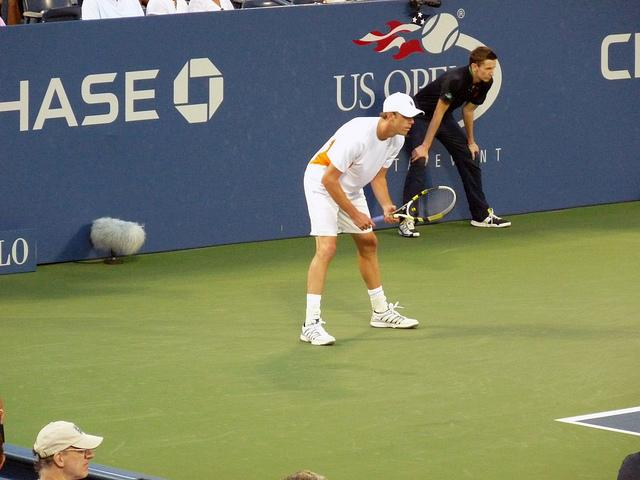What is the purpose of the white furry object?

Choices:
A) zoom in
B) amplify sound
C) hold balls
D) soften landing amplify sound 